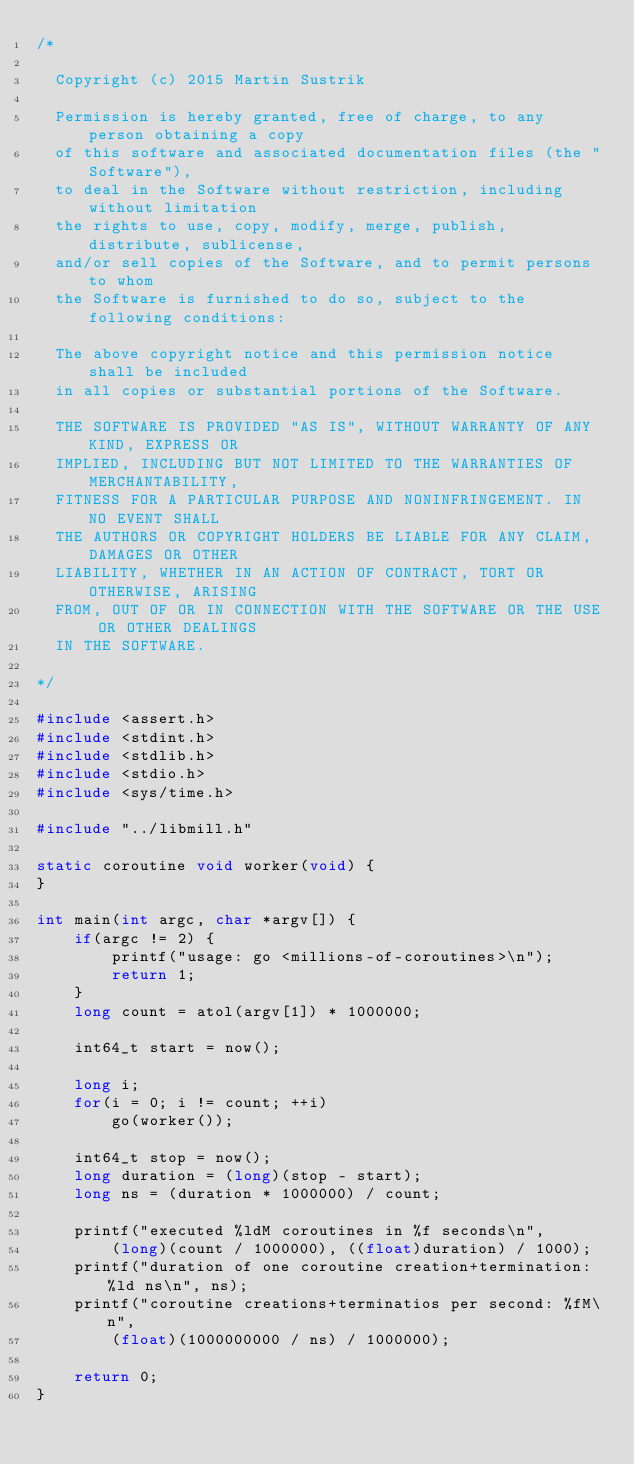<code> <loc_0><loc_0><loc_500><loc_500><_C_>/*

  Copyright (c) 2015 Martin Sustrik

  Permission is hereby granted, free of charge, to any person obtaining a copy
  of this software and associated documentation files (the "Software"),
  to deal in the Software without restriction, including without limitation
  the rights to use, copy, modify, merge, publish, distribute, sublicense,
  and/or sell copies of the Software, and to permit persons to whom
  the Software is furnished to do so, subject to the following conditions:

  The above copyright notice and this permission notice shall be included
  in all copies or substantial portions of the Software.

  THE SOFTWARE IS PROVIDED "AS IS", WITHOUT WARRANTY OF ANY KIND, EXPRESS OR
  IMPLIED, INCLUDING BUT NOT LIMITED TO THE WARRANTIES OF MERCHANTABILITY,
  FITNESS FOR A PARTICULAR PURPOSE AND NONINFRINGEMENT. IN NO EVENT SHALL
  THE AUTHORS OR COPYRIGHT HOLDERS BE LIABLE FOR ANY CLAIM, DAMAGES OR OTHER
  LIABILITY, WHETHER IN AN ACTION OF CONTRACT, TORT OR OTHERWISE, ARISING
  FROM, OUT OF OR IN CONNECTION WITH THE SOFTWARE OR THE USE OR OTHER DEALINGS
  IN THE SOFTWARE.

*/

#include <assert.h>
#include <stdint.h>
#include <stdlib.h>
#include <stdio.h>
#include <sys/time.h>

#include "../libmill.h"

static coroutine void worker(void) {
}

int main(int argc, char *argv[]) {
    if(argc != 2) {
        printf("usage: go <millions-of-coroutines>\n");
        return 1;
    }
    long count = atol(argv[1]) * 1000000;

    int64_t start = now();

    long i;
    for(i = 0; i != count; ++i)
        go(worker());

    int64_t stop = now();
    long duration = (long)(stop - start);
    long ns = (duration * 1000000) / count;

    printf("executed %ldM coroutines in %f seconds\n",
        (long)(count / 1000000), ((float)duration) / 1000);
    printf("duration of one coroutine creation+termination: %ld ns\n", ns);
    printf("coroutine creations+terminatios per second: %fM\n",
        (float)(1000000000 / ns) / 1000000);

    return 0;
}

</code> 